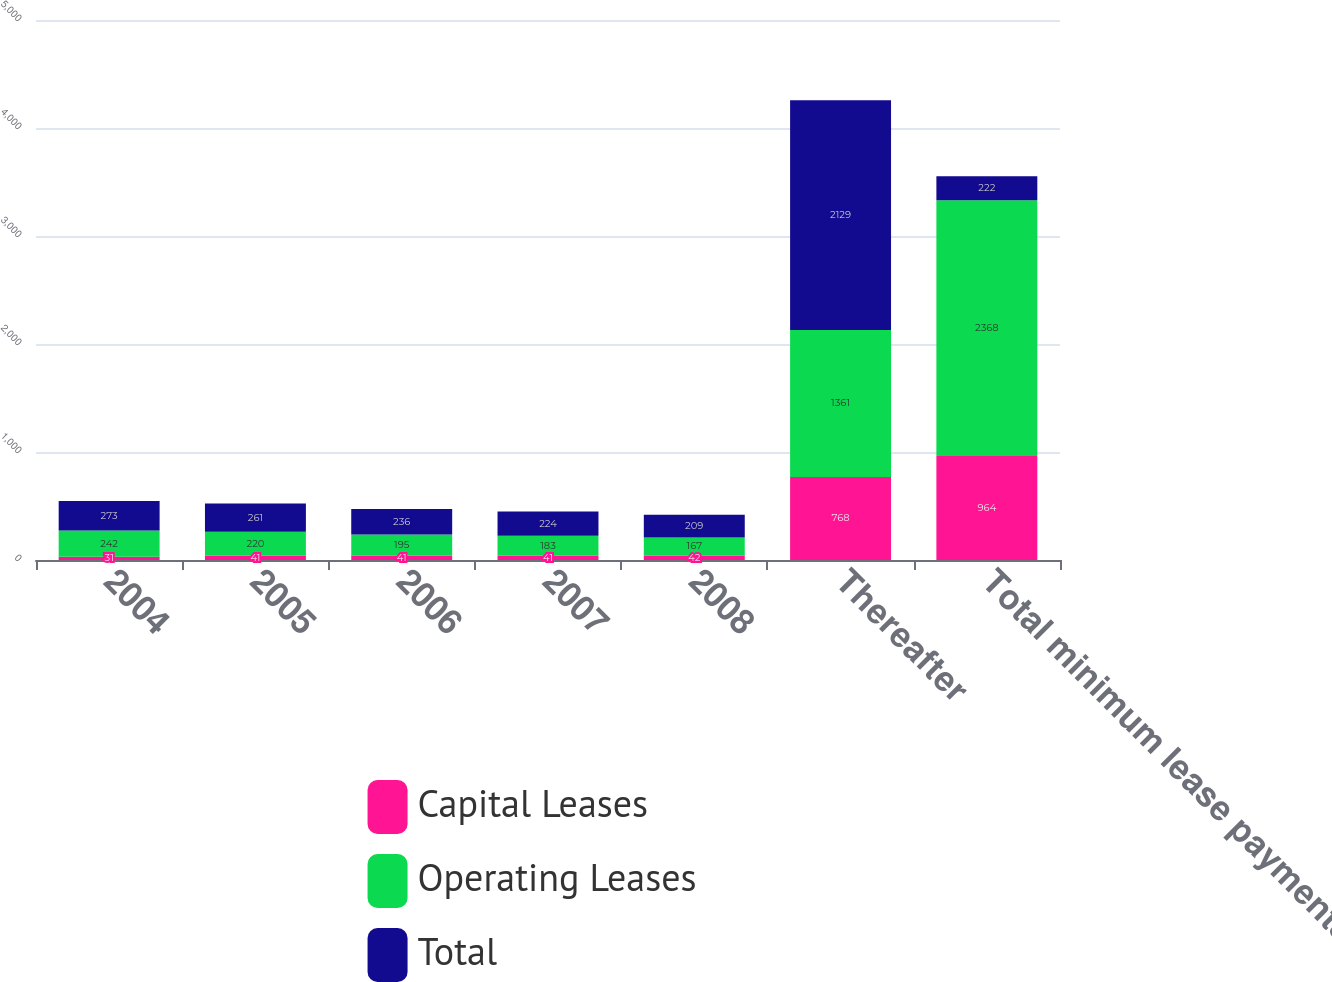<chart> <loc_0><loc_0><loc_500><loc_500><stacked_bar_chart><ecel><fcel>2004<fcel>2005<fcel>2006<fcel>2007<fcel>2008<fcel>Thereafter<fcel>Total minimum lease payments<nl><fcel>Capital Leases<fcel>31<fcel>41<fcel>41<fcel>41<fcel>42<fcel>768<fcel>964<nl><fcel>Operating Leases<fcel>242<fcel>220<fcel>195<fcel>183<fcel>167<fcel>1361<fcel>2368<nl><fcel>Total<fcel>273<fcel>261<fcel>236<fcel>224<fcel>209<fcel>2129<fcel>222<nl></chart> 